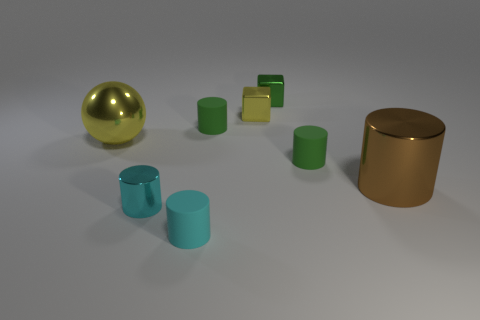The small rubber object that is behind the small cyan matte object and left of the tiny green metal block has what shape?
Ensure brevity in your answer.  Cylinder. Is the material of the tiny green object behind the tiny yellow cube the same as the big ball?
Ensure brevity in your answer.  Yes. Are there any other things that are the same material as the small yellow thing?
Give a very brief answer. Yes. There is another block that is the same size as the green cube; what color is it?
Your answer should be very brief. Yellow. Is there a small object that has the same color as the small shiny cylinder?
Provide a succinct answer. Yes. The yellow ball that is the same material as the big cylinder is what size?
Provide a succinct answer. Large. The metallic cube that is the same color as the metallic sphere is what size?
Ensure brevity in your answer.  Small. What number of other things are there of the same size as the green shiny cube?
Provide a succinct answer. 5. There is a tiny cylinder that is on the right side of the yellow cube; what is its material?
Provide a succinct answer. Rubber. There is a cyan object to the right of the cyan cylinder to the left of the small cyan thing that is in front of the tiny cyan metallic object; what is its shape?
Make the answer very short. Cylinder. 